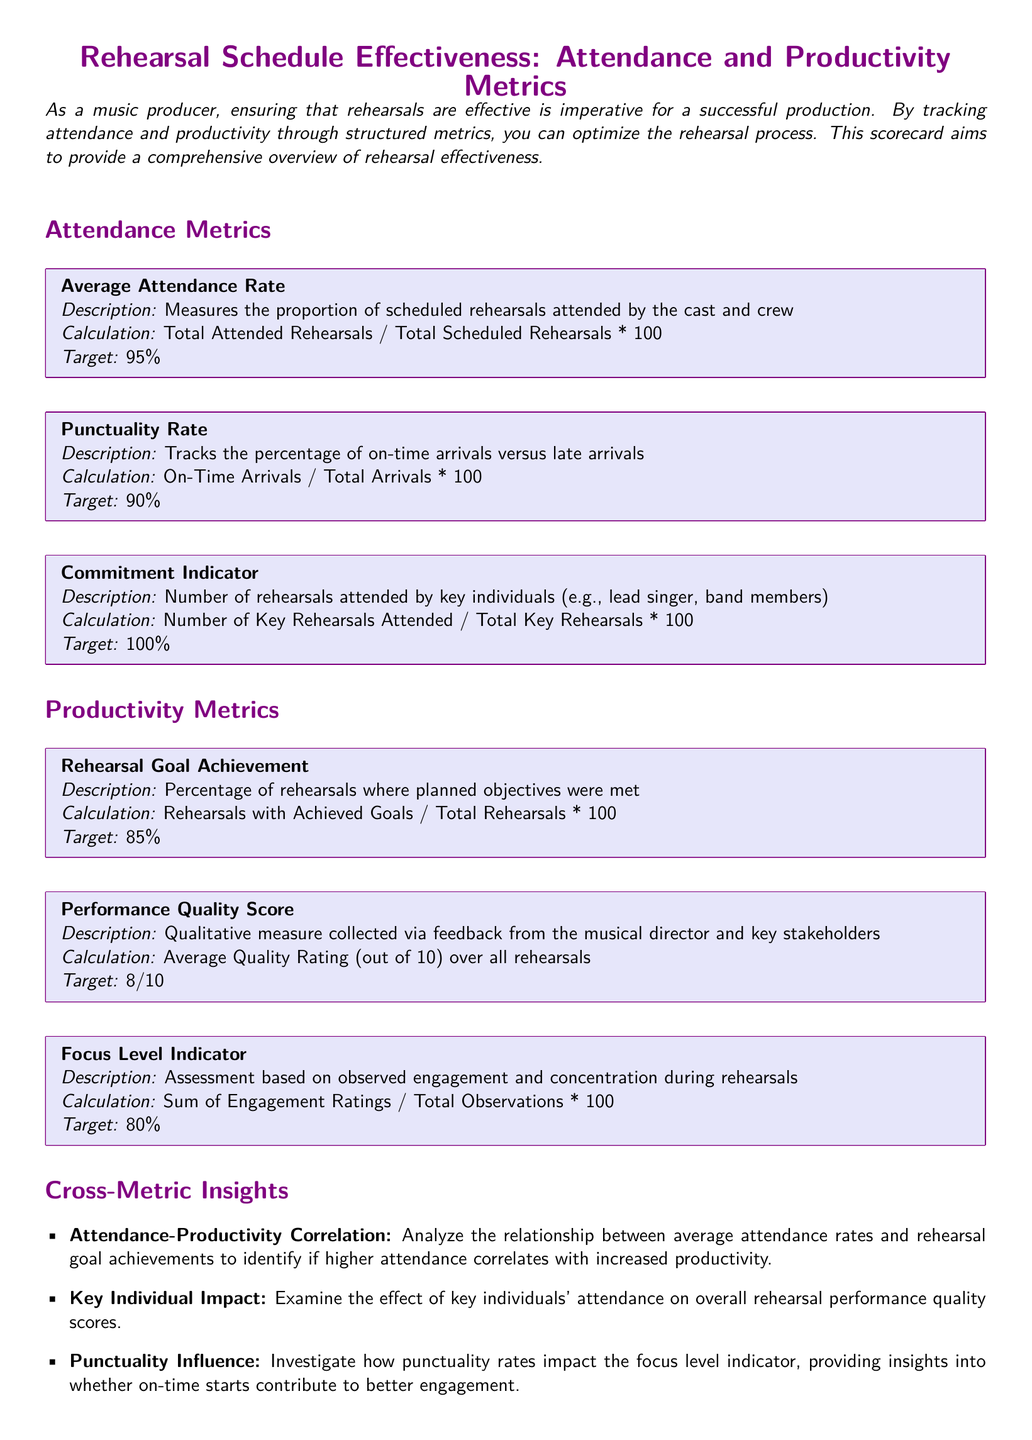What is the Average Attendance Rate? The Average Attendance Rate is calculated as the proportion of scheduled rehearsals attended by the cast and crew, which is stated in the document.
Answer: 95% What does the Punctuality Rate track? The document states that the Punctuality Rate tracks the percentage of on-time arrivals versus late arrivals.
Answer: Percentage of on-time arrivals What is the target for the Commitment Indicator? The target for the Commitment Indicator represents the number of rehearsals attended by key individuals, which is highlighted in the document.
Answer: 100% What percentage of rehearsals achieved their goals? The document specifies the percentage of rehearsals where planned objectives were met, known as Rehearsal Goal Achievement.
Answer: 85% What is the average Performance Quality Score? The document mentions the average quality rating collected via feedback from stakeholders, which contributes to the Performance Quality Score.
Answer: 8/10 What does the Focus Level Indicator assess? According to the document, the Focus Level Indicator assesses engagement and concentration during rehearsals.
Answer: Engagement and concentration How does attendance relate to productivity? The document suggests analyzing the relationship between average attendance rates and rehearsal goal achievements to understand correlation.
Answer: Attendance-productivity correlation What is the significance of key individuals' attendance? The document notes that examining key individuals' attendance can affect overall rehearsal performance quality scores.
Answer: Impact on performance quality scores What is the document type? The content and structure as outlined in the document is designed as a scorecard assessing rehearsal effectiveness.
Answer: Scorecard 